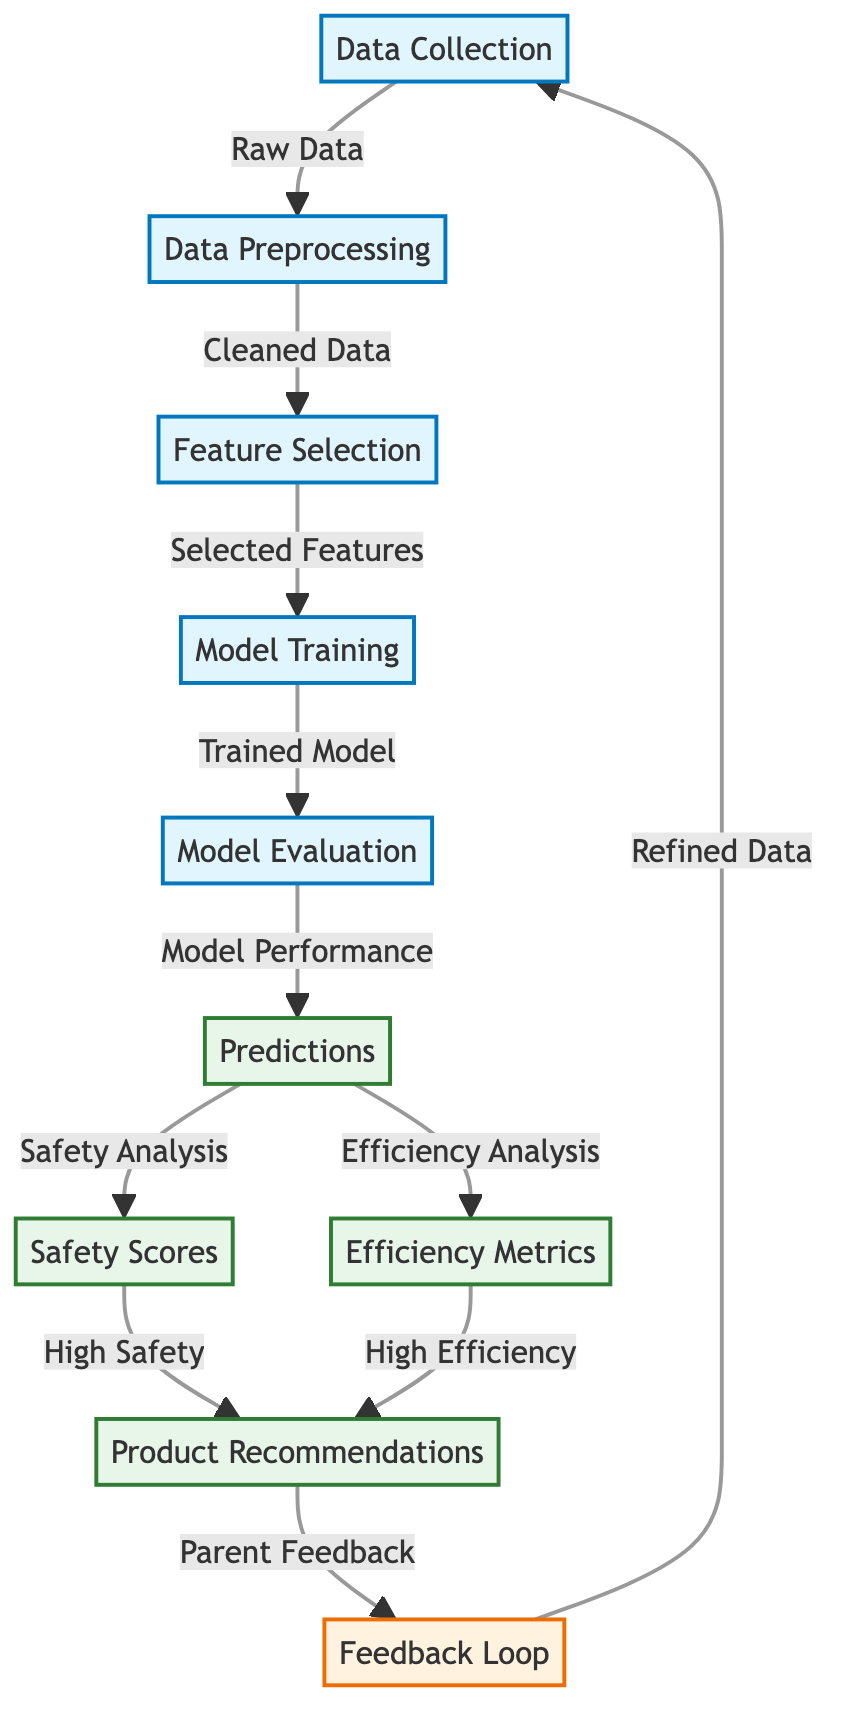What is the first step in the diagram? The diagram begins with the node labeled "Data Collection," which is the first step in the process.
Answer: Data Collection How many output nodes are there in the diagram? Counting the nodes, there are four output nodes: "Predictions," "Safety Scores," "Efficiency Metrics," and "Product Recommendations."
Answer: Four What type of data is produced after "Model Evaluation"? After "Model Evaluation," the diagram indicates that "Predictions" is generated.
Answer: Predictions Which node receives feedback to refine data? The node labeled "Feedback Loop" collects "Parent Feedback," which is then used to refine the data in the "Data Collection" node.
Answer: Feedback Loop What are the two analyses carried out after model predictions? Following the "Predictions" node, both "Safety Analysis" and "Efficiency Analysis" are conducted, as indicated by the arrows leading to "Safety Scores" and "Efficiency Metrics."
Answer: Safety Analysis and Efficiency Analysis What comes after "Feature Selection"? After "Feature Selection," the process moves to "Model Training," which is the subsequent step in the diagram.
Answer: Model Training What kind of data does the "Data Preprocessing" node handle? The "Data Preprocessing" node processes the "Raw Data" from "Data Collection" to produce "Cleaned Data" for further analysis.
Answer: Cleaned Data Which output node relates to the highest safety rating? The "Safety Scores" node is directly linked to the analysis of safety, indicating scores based on that criterion.
Answer: Safety Scores What is the purpose of the "Feedback Loop" in this diagram? The "Feedback Loop" gathers "Parent Feedback" to improve the data collection process, contributing to refining the product recommendations.
Answer: Refine Data 